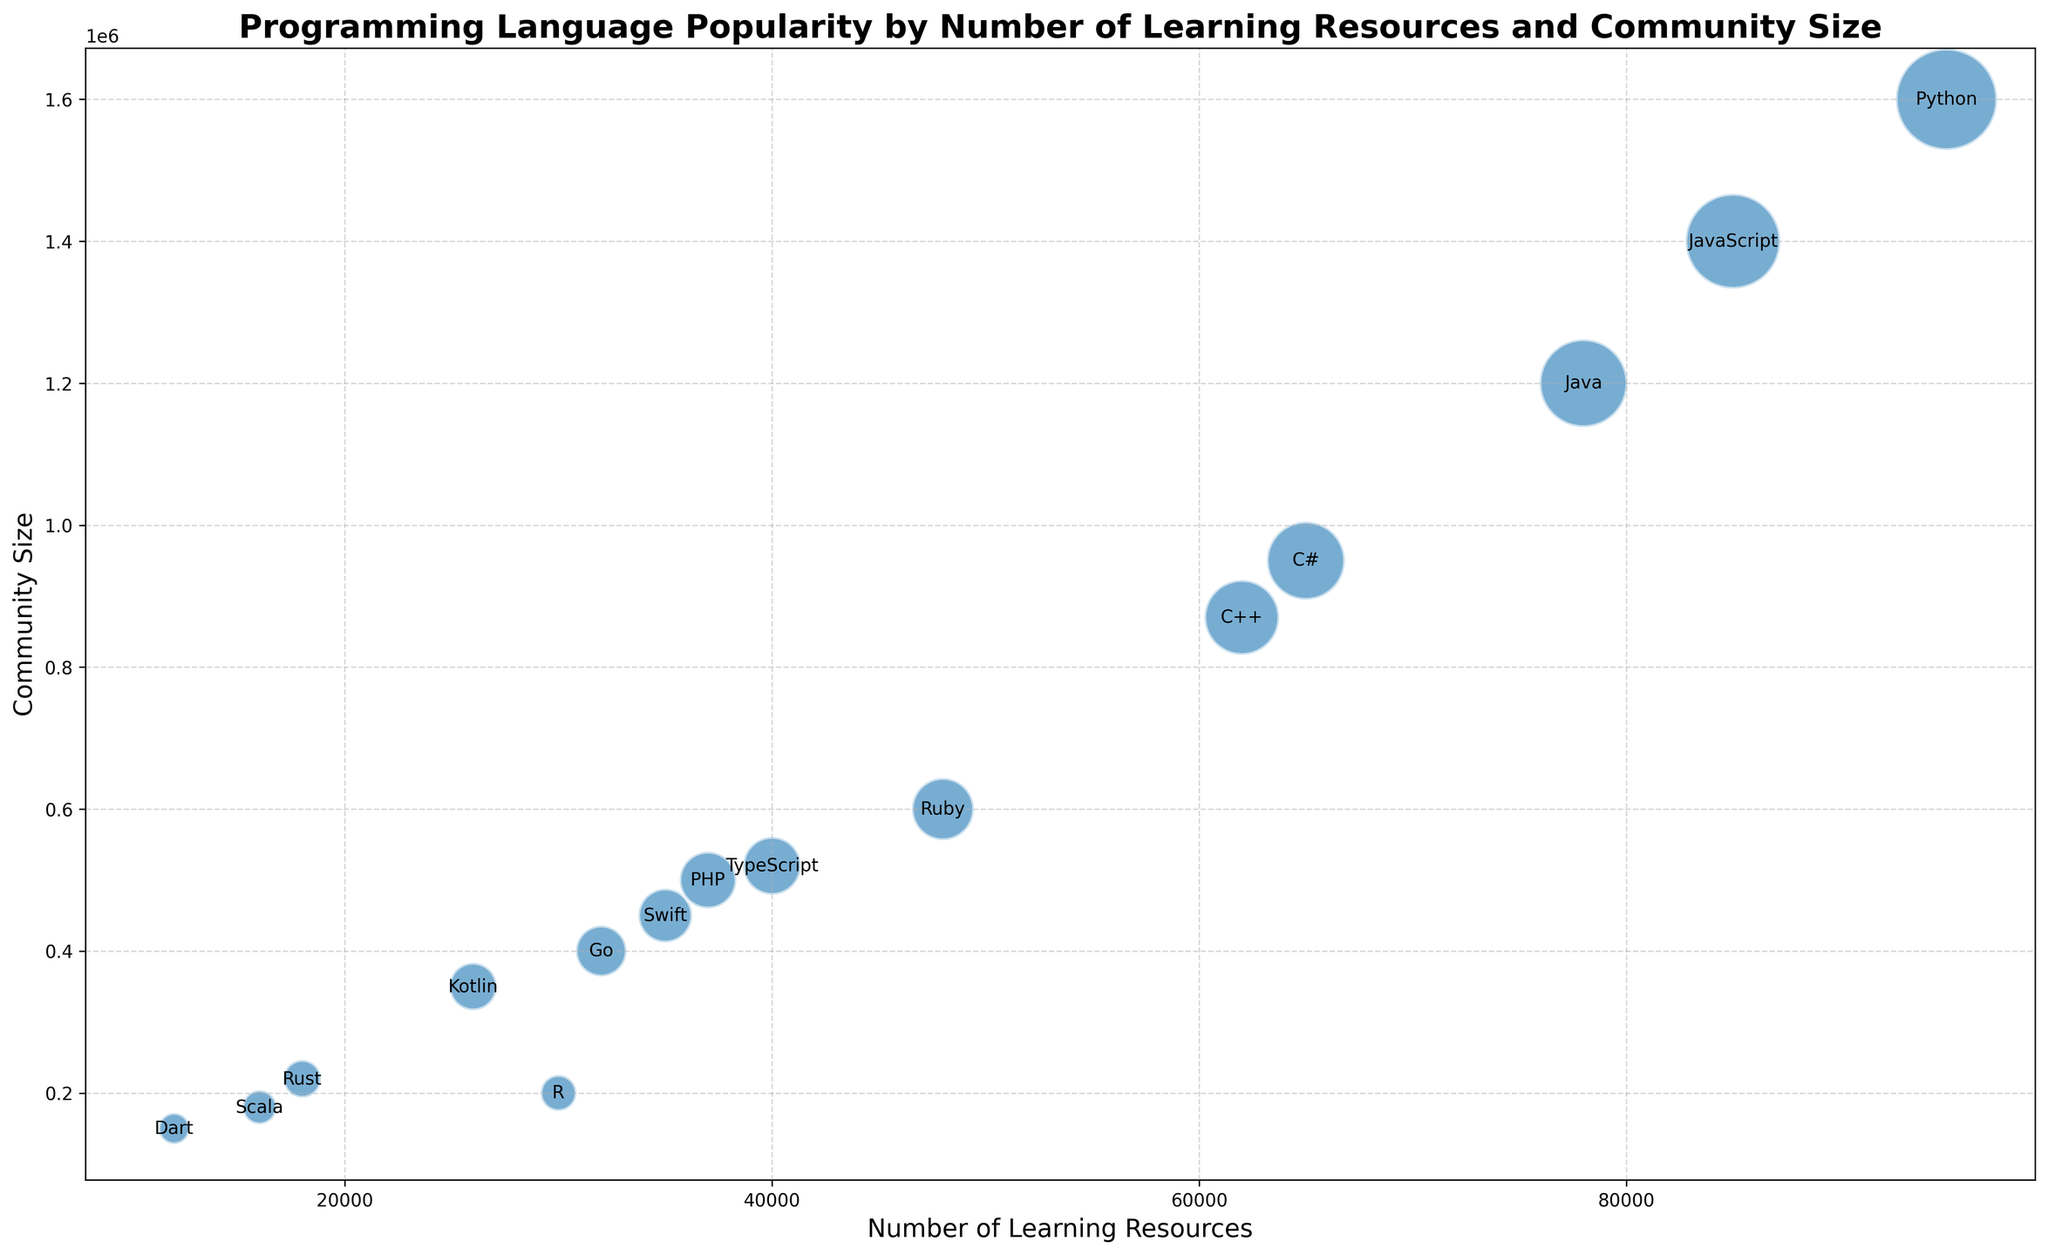what programming language has the highest number of learning resources? From the figure, identify the bubble that corresponds to the highest x-value, then check the label for that bubble.
Answer: Python which language has a smaller community size, Swift or PHP? Locate the bubbles for Swift and PHP, then compare their y-values. The bubble with the lower y-value represents the smaller community size.
Answer: Swift how does the community size of Java compare to Python? Find the bubbles for Java and Python, compare their y-values: higher y-values indicate larger community sizes.
Answer: Java has a smaller community size than Python what’s the total number of learning resources for Python and JavaScript combined? Add the x-values (number of learning resources) for Python and JavaScript. Python has 95,000 and JavaScript has 85,000. So, 95,000 + 85,000 = 180,000.
Answer: 180,000 which language has a larger bubble, Go or Kotlin? Compare the size of the bubbles for Go and Kotlin. Larger bubble indicates larger community size.
Answer: Go what is the difference in community size between C# and Rust? Identify and note y-values for C# and Rust, then subtract the community size of Rust from that of C#. C# has 950,000 and Rust has 220,000. So, 950,000 - 220,000 = 730,000.
Answer: 730,000 is the number of learning resources for R greater than for Go? Compare the x-values for R and Go. R has 30,000 while Go has 32,000.
Answer: No which language has roughly equal learning resources and community size? Look for bubbles where x (learning resources) and y (community size) values are similar. PHP has 37,000 learning resources and 50,000 community size.
Answer: PHP which has the smallest bubble on the chart? The smallest bubble represents the smallest community size. Locate the smallest bubble visually and check its label.
Answer: Dart what's the average community size of C++, Swift, and Ruby? First, sum the community sizes of C++ (870,000), Swift (450,000), and Ruby (600,000). Total is 1,920,000. Divide by 3 to get the average, so 1,920,000 / 3 = 640,000.
Answer: 640,000 